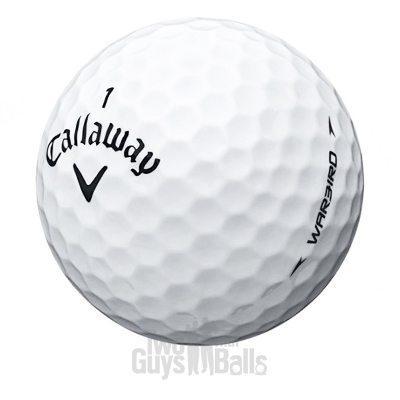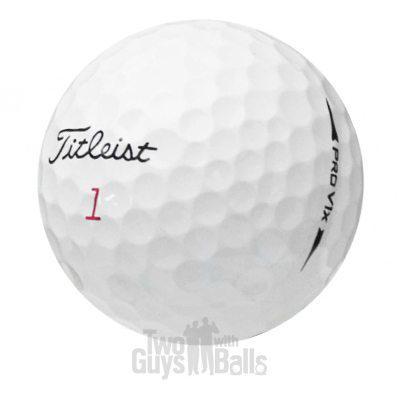The first image is the image on the left, the second image is the image on the right. Assess this claim about the two images: "In one of the images there is a golf ball with a face printed on it.". Correct or not? Answer yes or no. No. The first image is the image on the left, the second image is the image on the right. Examine the images to the left and right. Is the description "Exactly one standard white golf ball is shown in each image, with its brand name stamped in black and a number either above or below it." accurate? Answer yes or no. Yes. 